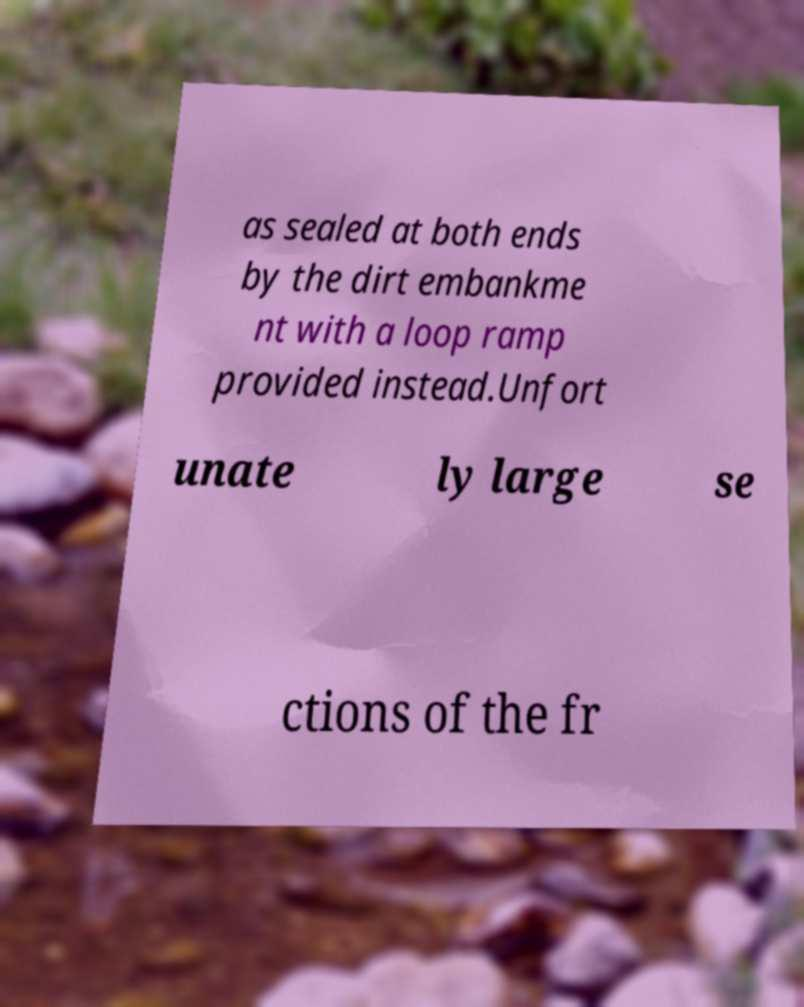I need the written content from this picture converted into text. Can you do that? as sealed at both ends by the dirt embankme nt with a loop ramp provided instead.Unfort unate ly large se ctions of the fr 